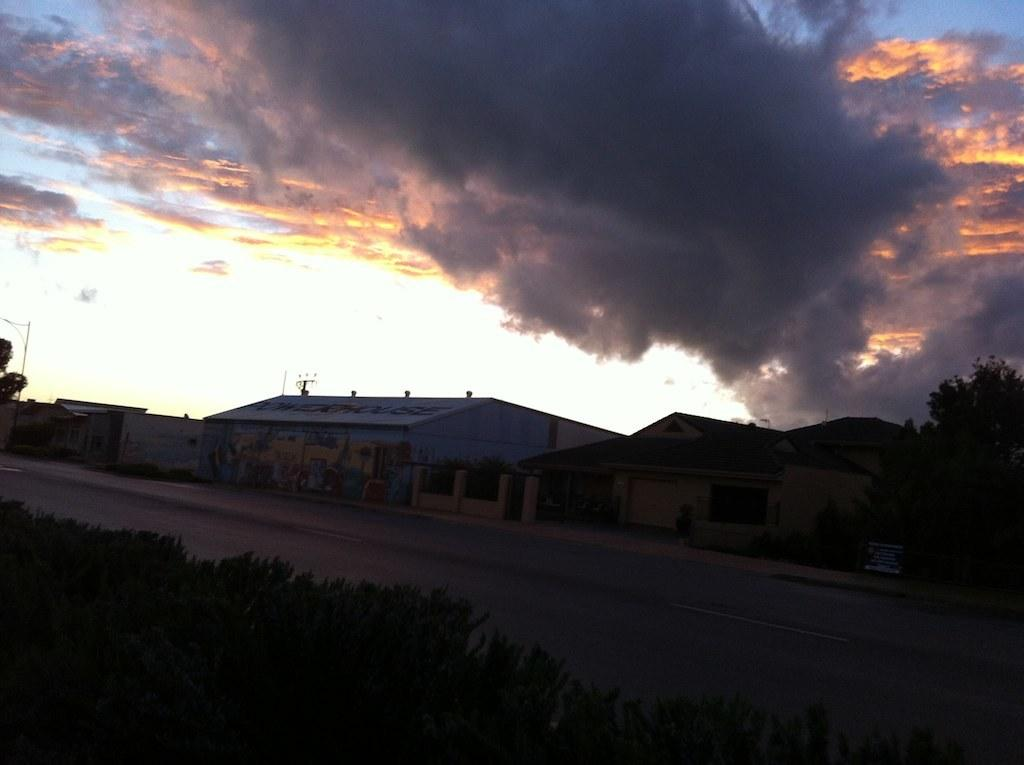What type of natural elements can be seen in the image? There are plants and trees in the image. What type of man-made structures are visible in the image? There are buildings in the image. What is visible in the sky in the image? There are clouds visible in the image. What type of vertical structures can be seen in the image? There are poles in the image. What type of cable can be seen connecting the trees in the image? There is no cable connecting the trees in the image; only plants, trees, buildings, clouds, and poles are present. What spot in the image is the most colorful? The provided facts do not mention any specific spot or area in the image being more colorful than others. 